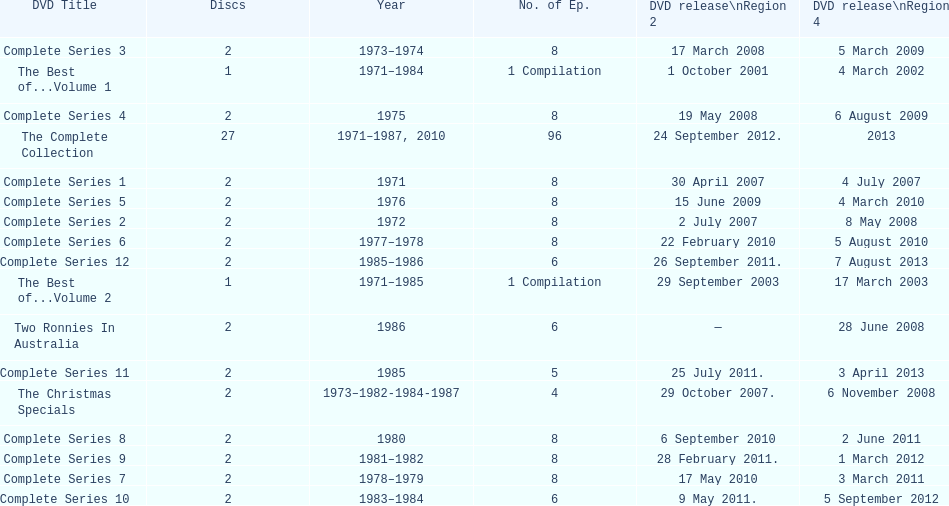Parse the full table. {'header': ['DVD Title', 'Discs', 'Year', 'No. of Ep.', 'DVD release\\nRegion 2', 'DVD release\\nRegion 4'], 'rows': [['Complete Series 3', '2', '1973–1974', '8', '17 March 2008', '5 March 2009'], ['The Best of...Volume 1', '1', '1971–1984', '1 Compilation', '1 October 2001', '4 March 2002'], ['Complete Series 4', '2', '1975', '8', '19 May 2008', '6 August 2009'], ['The Complete Collection', '27', '1971–1987, 2010', '96', '24 September 2012.', '2013'], ['Complete Series 1', '2', '1971', '8', '30 April 2007', '4 July 2007'], ['Complete Series 5', '2', '1976', '8', '15 June 2009', '4 March 2010'], ['Complete Series 2', '2', '1972', '8', '2 July 2007', '8 May 2008'], ['Complete Series 6', '2', '1977–1978', '8', '22 February 2010', '5 August 2010'], ['Complete Series 12', '2', '1985–1986', '6', '26 September 2011.', '7 August 2013'], ['The Best of...Volume 2', '1', '1971–1985', '1 Compilation', '29 September 2003', '17 March 2003'], ['Two Ronnies In Australia', '2', '1986', '6', '—', '28 June 2008'], ['Complete Series 11', '2', '1985', '5', '25 July 2011.', '3 April 2013'], ['The Christmas Specials', '2', '1973–1982-1984-1987', '4', '29 October 2007.', '6 November 2008'], ['Complete Series 8', '2', '1980', '8', '6 September 2010', '2 June 2011'], ['Complete Series 9', '2', '1981–1982', '8', '28 February 2011.', '1 March 2012'], ['Complete Series 7', '2', '1978–1979', '8', '17 May 2010', '3 March 2011'], ['Complete Series 10', '2', '1983–1984', '6', '9 May 2011.', '5 September 2012']]} Dvds with fewer than 5 episodes The Christmas Specials. 